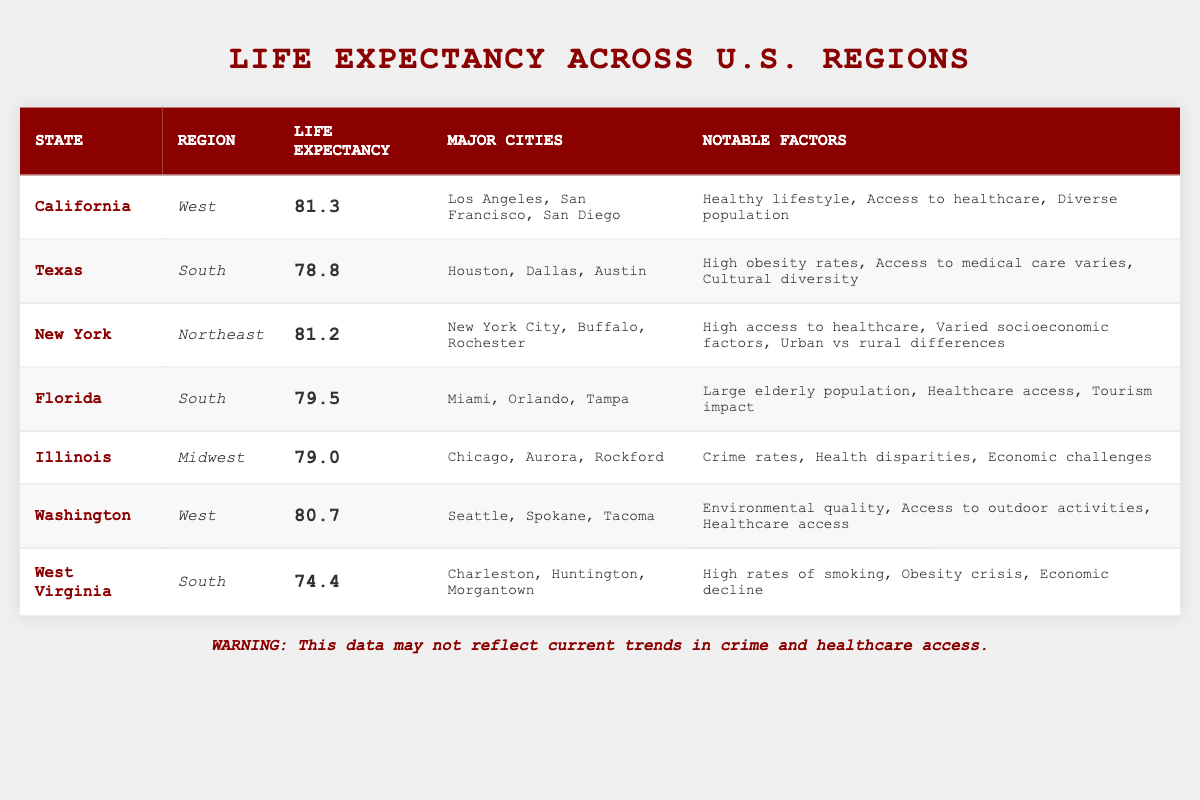What is the life expectancy in California? The table explicitly states that the life expectancy in California is listed under the life expectancy column next to the state name. It shows a value of 81.3 years.
Answer: 81.3 Which state has the lowest life expectancy? By reviewing the life expectancy values in the table, West Virginia is identified as having the lowest value at 74.4 years, as it is the smallest number in the life expectancy column.
Answer: West Virginia What is the average life expectancy of the states in the South region? The South region includes Texas (78.8), Florida (79.5), and West Virginia (74.4). We sum these values (78.8 + 79.5 + 74.4) = 232.7 and then divide by the number of states (3), which gives 232.7/3 = 77.57.
Answer: 77.57 Does New York have a higher life expectancy than Florida? The life expectancy for New York is 81.2 years and for Florida, it is 79.5 years. Since 81.2 is greater than 79.5, the statement that New York has a higher life expectancy than Florida is true.
Answer: Yes Which region has the highest life expectancy, and what is that value? By comparing the life expectancies across all regions, we find California in the West has the highest life expectancy at 81.3 years. Therefore, the West region has the highest life expectancy.
Answer: West, 81.3 What notable factor is mentioned for Illinois? The table indicates that for Illinois, the notable factors include crime rates, health disparities, and economic challenges. The question asked for a specific notable factor, which can be clearly identified within the listed factors.
Answer: Crime rates How many states have a life expectancy above 80 years? The states with a life expectancy above 80 years are California (81.3) and New York (81.2), which sums to two states.
Answer: 2 Is access to healthcare listed as a notable factor for more than one state? Upon examining the notable factors for each state, both California and Washington list access to healthcare as a notable factor. Since it appears in two different states, the answer to the query is affirmative.
Answer: Yes 